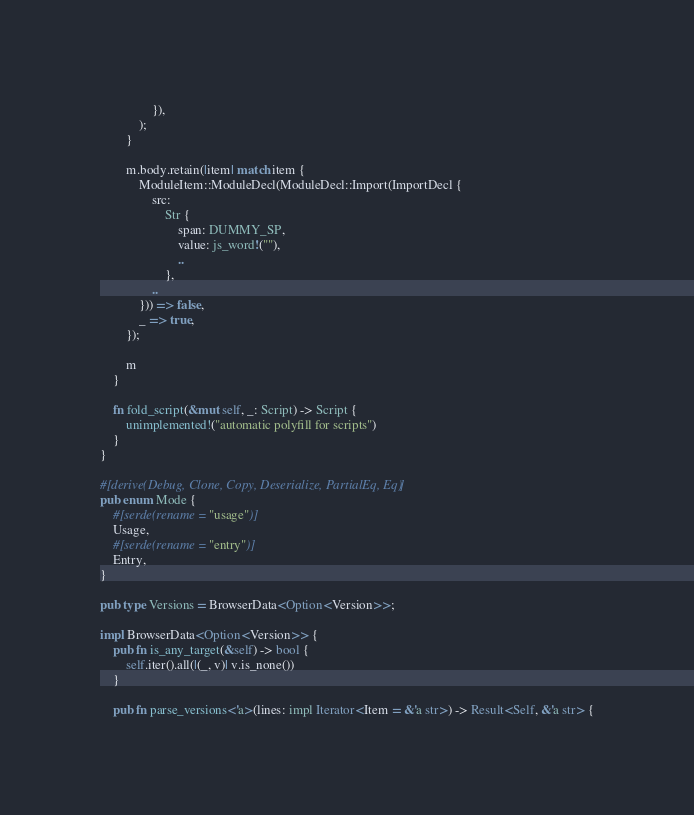Convert code to text. <code><loc_0><loc_0><loc_500><loc_500><_Rust_>                }),
            );
        }

        m.body.retain(|item| match item {
            ModuleItem::ModuleDecl(ModuleDecl::Import(ImportDecl {
                src:
                    Str {
                        span: DUMMY_SP,
                        value: js_word!(""),
                        ..
                    },
                ..
            })) => false,
            _ => true,
        });

        m
    }

    fn fold_script(&mut self, _: Script) -> Script {
        unimplemented!("automatic polyfill for scripts")
    }
}

#[derive(Debug, Clone, Copy, Deserialize, PartialEq, Eq)]
pub enum Mode {
    #[serde(rename = "usage")]
    Usage,
    #[serde(rename = "entry")]
    Entry,
}

pub type Versions = BrowserData<Option<Version>>;

impl BrowserData<Option<Version>> {
    pub fn is_any_target(&self) -> bool {
        self.iter().all(|(_, v)| v.is_none())
    }

    pub fn parse_versions<'a>(lines: impl Iterator<Item = &'a str>) -> Result<Self, &'a str> {</code> 